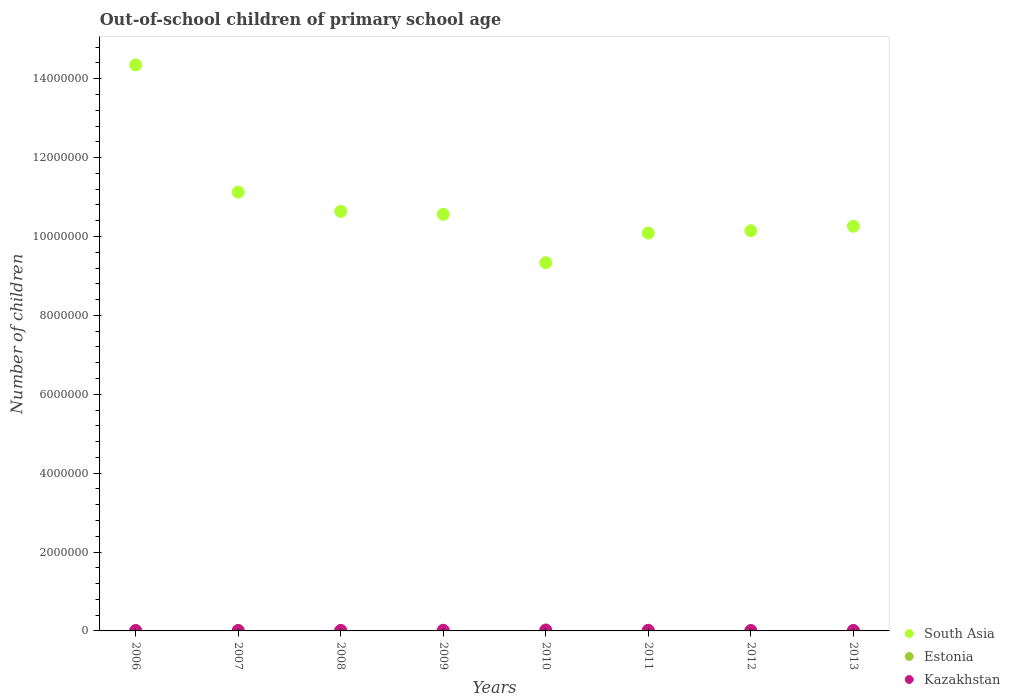How many different coloured dotlines are there?
Make the answer very short. 3. What is the number of out-of-school children in Estonia in 2011?
Your answer should be very brief. 2728. Across all years, what is the maximum number of out-of-school children in Kazakhstan?
Your response must be concise. 2.37e+04. Across all years, what is the minimum number of out-of-school children in Kazakhstan?
Your answer should be compact. 1.01e+04. In which year was the number of out-of-school children in Kazakhstan minimum?
Ensure brevity in your answer.  2012. What is the total number of out-of-school children in Kazakhstan in the graph?
Your answer should be very brief. 1.16e+05. What is the difference between the number of out-of-school children in South Asia in 2012 and that in 2013?
Provide a short and direct response. -1.15e+05. What is the difference between the number of out-of-school children in Estonia in 2006 and the number of out-of-school children in Kazakhstan in 2010?
Your response must be concise. -2.13e+04. What is the average number of out-of-school children in South Asia per year?
Offer a very short reply. 1.08e+07. In the year 2009, what is the difference between the number of out-of-school children in South Asia and number of out-of-school children in Estonia?
Provide a succinct answer. 1.06e+07. What is the ratio of the number of out-of-school children in Kazakhstan in 2011 to that in 2012?
Your response must be concise. 1.64. Is the difference between the number of out-of-school children in South Asia in 2009 and 2013 greater than the difference between the number of out-of-school children in Estonia in 2009 and 2013?
Ensure brevity in your answer.  Yes. What is the difference between the highest and the second highest number of out-of-school children in South Asia?
Keep it short and to the point. 3.23e+06. What is the difference between the highest and the lowest number of out-of-school children in South Asia?
Your response must be concise. 5.02e+06. Is the sum of the number of out-of-school children in South Asia in 2007 and 2010 greater than the maximum number of out-of-school children in Kazakhstan across all years?
Provide a short and direct response. Yes. Is it the case that in every year, the sum of the number of out-of-school children in Kazakhstan and number of out-of-school children in South Asia  is greater than the number of out-of-school children in Estonia?
Provide a succinct answer. Yes. Is the number of out-of-school children in Estonia strictly greater than the number of out-of-school children in South Asia over the years?
Keep it short and to the point. No. How many dotlines are there?
Your answer should be very brief. 3. Are the values on the major ticks of Y-axis written in scientific E-notation?
Your answer should be very brief. No. Does the graph contain any zero values?
Offer a terse response. No. How many legend labels are there?
Your response must be concise. 3. How are the legend labels stacked?
Your response must be concise. Vertical. What is the title of the graph?
Keep it short and to the point. Out-of-school children of primary school age. Does "Macedonia" appear as one of the legend labels in the graph?
Your response must be concise. No. What is the label or title of the Y-axis?
Keep it short and to the point. Number of children. What is the Number of children of South Asia in 2006?
Provide a short and direct response. 1.44e+07. What is the Number of children of Estonia in 2006?
Provide a succinct answer. 2464. What is the Number of children of Kazakhstan in 2006?
Offer a terse response. 1.10e+04. What is the Number of children of South Asia in 2007?
Offer a very short reply. 1.11e+07. What is the Number of children of Estonia in 2007?
Your response must be concise. 3067. What is the Number of children in Kazakhstan in 2007?
Offer a terse response. 1.13e+04. What is the Number of children in South Asia in 2008?
Offer a very short reply. 1.06e+07. What is the Number of children in Estonia in 2008?
Give a very brief answer. 2521. What is the Number of children of Kazakhstan in 2008?
Provide a succinct answer. 1.33e+04. What is the Number of children in South Asia in 2009?
Your answer should be compact. 1.06e+07. What is the Number of children in Estonia in 2009?
Your response must be concise. 2495. What is the Number of children of Kazakhstan in 2009?
Make the answer very short. 1.70e+04. What is the Number of children of South Asia in 2010?
Provide a short and direct response. 9.33e+06. What is the Number of children in Estonia in 2010?
Make the answer very short. 2112. What is the Number of children in Kazakhstan in 2010?
Ensure brevity in your answer.  2.37e+04. What is the Number of children of South Asia in 2011?
Give a very brief answer. 1.01e+07. What is the Number of children of Estonia in 2011?
Your answer should be compact. 2728. What is the Number of children of Kazakhstan in 2011?
Your answer should be very brief. 1.66e+04. What is the Number of children of South Asia in 2012?
Offer a very short reply. 1.01e+07. What is the Number of children of Estonia in 2012?
Give a very brief answer. 2385. What is the Number of children of Kazakhstan in 2012?
Give a very brief answer. 1.01e+04. What is the Number of children in South Asia in 2013?
Make the answer very short. 1.03e+07. What is the Number of children of Estonia in 2013?
Offer a very short reply. 2280. What is the Number of children in Kazakhstan in 2013?
Make the answer very short. 1.25e+04. Across all years, what is the maximum Number of children of South Asia?
Offer a very short reply. 1.44e+07. Across all years, what is the maximum Number of children of Estonia?
Offer a terse response. 3067. Across all years, what is the maximum Number of children of Kazakhstan?
Offer a very short reply. 2.37e+04. Across all years, what is the minimum Number of children in South Asia?
Provide a short and direct response. 9.33e+06. Across all years, what is the minimum Number of children in Estonia?
Provide a succinct answer. 2112. Across all years, what is the minimum Number of children of Kazakhstan?
Your response must be concise. 1.01e+04. What is the total Number of children in South Asia in the graph?
Offer a terse response. 8.65e+07. What is the total Number of children of Estonia in the graph?
Keep it short and to the point. 2.01e+04. What is the total Number of children in Kazakhstan in the graph?
Make the answer very short. 1.16e+05. What is the difference between the Number of children of South Asia in 2006 and that in 2007?
Provide a short and direct response. 3.23e+06. What is the difference between the Number of children of Estonia in 2006 and that in 2007?
Give a very brief answer. -603. What is the difference between the Number of children in Kazakhstan in 2006 and that in 2007?
Your answer should be very brief. -242. What is the difference between the Number of children of South Asia in 2006 and that in 2008?
Make the answer very short. 3.71e+06. What is the difference between the Number of children of Estonia in 2006 and that in 2008?
Your answer should be very brief. -57. What is the difference between the Number of children of Kazakhstan in 2006 and that in 2008?
Your response must be concise. -2242. What is the difference between the Number of children in South Asia in 2006 and that in 2009?
Provide a succinct answer. 3.79e+06. What is the difference between the Number of children of Estonia in 2006 and that in 2009?
Offer a terse response. -31. What is the difference between the Number of children of Kazakhstan in 2006 and that in 2009?
Offer a very short reply. -5917. What is the difference between the Number of children in South Asia in 2006 and that in 2010?
Your response must be concise. 5.02e+06. What is the difference between the Number of children of Estonia in 2006 and that in 2010?
Your answer should be compact. 352. What is the difference between the Number of children of Kazakhstan in 2006 and that in 2010?
Your answer should be very brief. -1.27e+04. What is the difference between the Number of children of South Asia in 2006 and that in 2011?
Ensure brevity in your answer.  4.26e+06. What is the difference between the Number of children in Estonia in 2006 and that in 2011?
Keep it short and to the point. -264. What is the difference between the Number of children in Kazakhstan in 2006 and that in 2011?
Offer a very short reply. -5518. What is the difference between the Number of children of South Asia in 2006 and that in 2012?
Keep it short and to the point. 4.21e+06. What is the difference between the Number of children of Estonia in 2006 and that in 2012?
Make the answer very short. 79. What is the difference between the Number of children of Kazakhstan in 2006 and that in 2012?
Offer a terse response. 932. What is the difference between the Number of children of South Asia in 2006 and that in 2013?
Provide a short and direct response. 4.09e+06. What is the difference between the Number of children in Estonia in 2006 and that in 2013?
Your answer should be very brief. 184. What is the difference between the Number of children of Kazakhstan in 2006 and that in 2013?
Your answer should be very brief. -1473. What is the difference between the Number of children in South Asia in 2007 and that in 2008?
Give a very brief answer. 4.87e+05. What is the difference between the Number of children of Estonia in 2007 and that in 2008?
Provide a short and direct response. 546. What is the difference between the Number of children in Kazakhstan in 2007 and that in 2008?
Your response must be concise. -2000. What is the difference between the Number of children of South Asia in 2007 and that in 2009?
Your answer should be very brief. 5.61e+05. What is the difference between the Number of children of Estonia in 2007 and that in 2009?
Make the answer very short. 572. What is the difference between the Number of children in Kazakhstan in 2007 and that in 2009?
Your answer should be compact. -5675. What is the difference between the Number of children of South Asia in 2007 and that in 2010?
Your response must be concise. 1.79e+06. What is the difference between the Number of children of Estonia in 2007 and that in 2010?
Offer a very short reply. 955. What is the difference between the Number of children of Kazakhstan in 2007 and that in 2010?
Your response must be concise. -1.24e+04. What is the difference between the Number of children in South Asia in 2007 and that in 2011?
Keep it short and to the point. 1.04e+06. What is the difference between the Number of children in Estonia in 2007 and that in 2011?
Provide a succinct answer. 339. What is the difference between the Number of children in Kazakhstan in 2007 and that in 2011?
Give a very brief answer. -5276. What is the difference between the Number of children of South Asia in 2007 and that in 2012?
Provide a short and direct response. 9.79e+05. What is the difference between the Number of children in Estonia in 2007 and that in 2012?
Make the answer very short. 682. What is the difference between the Number of children of Kazakhstan in 2007 and that in 2012?
Offer a very short reply. 1174. What is the difference between the Number of children of South Asia in 2007 and that in 2013?
Ensure brevity in your answer.  8.64e+05. What is the difference between the Number of children of Estonia in 2007 and that in 2013?
Provide a succinct answer. 787. What is the difference between the Number of children of Kazakhstan in 2007 and that in 2013?
Provide a short and direct response. -1231. What is the difference between the Number of children of South Asia in 2008 and that in 2009?
Offer a very short reply. 7.44e+04. What is the difference between the Number of children of Kazakhstan in 2008 and that in 2009?
Ensure brevity in your answer.  -3675. What is the difference between the Number of children of South Asia in 2008 and that in 2010?
Make the answer very short. 1.30e+06. What is the difference between the Number of children in Estonia in 2008 and that in 2010?
Make the answer very short. 409. What is the difference between the Number of children in Kazakhstan in 2008 and that in 2010?
Provide a succinct answer. -1.04e+04. What is the difference between the Number of children of South Asia in 2008 and that in 2011?
Provide a short and direct response. 5.51e+05. What is the difference between the Number of children of Estonia in 2008 and that in 2011?
Offer a very short reply. -207. What is the difference between the Number of children of Kazakhstan in 2008 and that in 2011?
Provide a short and direct response. -3276. What is the difference between the Number of children in South Asia in 2008 and that in 2012?
Provide a short and direct response. 4.92e+05. What is the difference between the Number of children of Estonia in 2008 and that in 2012?
Offer a very short reply. 136. What is the difference between the Number of children in Kazakhstan in 2008 and that in 2012?
Give a very brief answer. 3174. What is the difference between the Number of children of South Asia in 2008 and that in 2013?
Keep it short and to the point. 3.78e+05. What is the difference between the Number of children of Estonia in 2008 and that in 2013?
Make the answer very short. 241. What is the difference between the Number of children in Kazakhstan in 2008 and that in 2013?
Offer a terse response. 769. What is the difference between the Number of children of South Asia in 2009 and that in 2010?
Offer a very short reply. 1.23e+06. What is the difference between the Number of children in Estonia in 2009 and that in 2010?
Give a very brief answer. 383. What is the difference between the Number of children in Kazakhstan in 2009 and that in 2010?
Your response must be concise. -6757. What is the difference between the Number of children of South Asia in 2009 and that in 2011?
Keep it short and to the point. 4.76e+05. What is the difference between the Number of children of Estonia in 2009 and that in 2011?
Your answer should be very brief. -233. What is the difference between the Number of children in Kazakhstan in 2009 and that in 2011?
Offer a very short reply. 399. What is the difference between the Number of children of South Asia in 2009 and that in 2012?
Your response must be concise. 4.18e+05. What is the difference between the Number of children of Estonia in 2009 and that in 2012?
Make the answer very short. 110. What is the difference between the Number of children in Kazakhstan in 2009 and that in 2012?
Your answer should be very brief. 6849. What is the difference between the Number of children of South Asia in 2009 and that in 2013?
Your response must be concise. 3.03e+05. What is the difference between the Number of children in Estonia in 2009 and that in 2013?
Offer a terse response. 215. What is the difference between the Number of children of Kazakhstan in 2009 and that in 2013?
Your answer should be compact. 4444. What is the difference between the Number of children of South Asia in 2010 and that in 2011?
Make the answer very short. -7.51e+05. What is the difference between the Number of children of Estonia in 2010 and that in 2011?
Offer a terse response. -616. What is the difference between the Number of children in Kazakhstan in 2010 and that in 2011?
Make the answer very short. 7156. What is the difference between the Number of children of South Asia in 2010 and that in 2012?
Keep it short and to the point. -8.10e+05. What is the difference between the Number of children of Estonia in 2010 and that in 2012?
Ensure brevity in your answer.  -273. What is the difference between the Number of children in Kazakhstan in 2010 and that in 2012?
Your answer should be compact. 1.36e+04. What is the difference between the Number of children in South Asia in 2010 and that in 2013?
Give a very brief answer. -9.24e+05. What is the difference between the Number of children of Estonia in 2010 and that in 2013?
Your answer should be compact. -168. What is the difference between the Number of children in Kazakhstan in 2010 and that in 2013?
Provide a succinct answer. 1.12e+04. What is the difference between the Number of children of South Asia in 2011 and that in 2012?
Offer a very short reply. -5.81e+04. What is the difference between the Number of children of Estonia in 2011 and that in 2012?
Ensure brevity in your answer.  343. What is the difference between the Number of children of Kazakhstan in 2011 and that in 2012?
Ensure brevity in your answer.  6450. What is the difference between the Number of children in South Asia in 2011 and that in 2013?
Your answer should be compact. -1.73e+05. What is the difference between the Number of children in Estonia in 2011 and that in 2013?
Your answer should be compact. 448. What is the difference between the Number of children in Kazakhstan in 2011 and that in 2013?
Offer a terse response. 4045. What is the difference between the Number of children in South Asia in 2012 and that in 2013?
Offer a very short reply. -1.15e+05. What is the difference between the Number of children in Estonia in 2012 and that in 2013?
Offer a very short reply. 105. What is the difference between the Number of children in Kazakhstan in 2012 and that in 2013?
Keep it short and to the point. -2405. What is the difference between the Number of children of South Asia in 2006 and the Number of children of Estonia in 2007?
Offer a terse response. 1.43e+07. What is the difference between the Number of children of South Asia in 2006 and the Number of children of Kazakhstan in 2007?
Provide a succinct answer. 1.43e+07. What is the difference between the Number of children in Estonia in 2006 and the Number of children in Kazakhstan in 2007?
Your response must be concise. -8824. What is the difference between the Number of children of South Asia in 2006 and the Number of children of Estonia in 2008?
Your answer should be compact. 1.43e+07. What is the difference between the Number of children of South Asia in 2006 and the Number of children of Kazakhstan in 2008?
Your answer should be very brief. 1.43e+07. What is the difference between the Number of children in Estonia in 2006 and the Number of children in Kazakhstan in 2008?
Your answer should be compact. -1.08e+04. What is the difference between the Number of children in South Asia in 2006 and the Number of children in Estonia in 2009?
Give a very brief answer. 1.43e+07. What is the difference between the Number of children of South Asia in 2006 and the Number of children of Kazakhstan in 2009?
Make the answer very short. 1.43e+07. What is the difference between the Number of children of Estonia in 2006 and the Number of children of Kazakhstan in 2009?
Keep it short and to the point. -1.45e+04. What is the difference between the Number of children in South Asia in 2006 and the Number of children in Estonia in 2010?
Give a very brief answer. 1.43e+07. What is the difference between the Number of children in South Asia in 2006 and the Number of children in Kazakhstan in 2010?
Offer a terse response. 1.43e+07. What is the difference between the Number of children of Estonia in 2006 and the Number of children of Kazakhstan in 2010?
Keep it short and to the point. -2.13e+04. What is the difference between the Number of children of South Asia in 2006 and the Number of children of Estonia in 2011?
Offer a terse response. 1.43e+07. What is the difference between the Number of children in South Asia in 2006 and the Number of children in Kazakhstan in 2011?
Provide a short and direct response. 1.43e+07. What is the difference between the Number of children of Estonia in 2006 and the Number of children of Kazakhstan in 2011?
Your response must be concise. -1.41e+04. What is the difference between the Number of children of South Asia in 2006 and the Number of children of Estonia in 2012?
Provide a succinct answer. 1.43e+07. What is the difference between the Number of children of South Asia in 2006 and the Number of children of Kazakhstan in 2012?
Provide a succinct answer. 1.43e+07. What is the difference between the Number of children of Estonia in 2006 and the Number of children of Kazakhstan in 2012?
Your answer should be very brief. -7650. What is the difference between the Number of children in South Asia in 2006 and the Number of children in Estonia in 2013?
Keep it short and to the point. 1.43e+07. What is the difference between the Number of children in South Asia in 2006 and the Number of children in Kazakhstan in 2013?
Give a very brief answer. 1.43e+07. What is the difference between the Number of children in Estonia in 2006 and the Number of children in Kazakhstan in 2013?
Offer a terse response. -1.01e+04. What is the difference between the Number of children of South Asia in 2007 and the Number of children of Estonia in 2008?
Your answer should be compact. 1.11e+07. What is the difference between the Number of children of South Asia in 2007 and the Number of children of Kazakhstan in 2008?
Make the answer very short. 1.11e+07. What is the difference between the Number of children of Estonia in 2007 and the Number of children of Kazakhstan in 2008?
Give a very brief answer. -1.02e+04. What is the difference between the Number of children in South Asia in 2007 and the Number of children in Estonia in 2009?
Your response must be concise. 1.11e+07. What is the difference between the Number of children of South Asia in 2007 and the Number of children of Kazakhstan in 2009?
Make the answer very short. 1.11e+07. What is the difference between the Number of children in Estonia in 2007 and the Number of children in Kazakhstan in 2009?
Give a very brief answer. -1.39e+04. What is the difference between the Number of children in South Asia in 2007 and the Number of children in Estonia in 2010?
Give a very brief answer. 1.11e+07. What is the difference between the Number of children in South Asia in 2007 and the Number of children in Kazakhstan in 2010?
Offer a terse response. 1.11e+07. What is the difference between the Number of children of Estonia in 2007 and the Number of children of Kazakhstan in 2010?
Your answer should be very brief. -2.07e+04. What is the difference between the Number of children of South Asia in 2007 and the Number of children of Estonia in 2011?
Provide a short and direct response. 1.11e+07. What is the difference between the Number of children in South Asia in 2007 and the Number of children in Kazakhstan in 2011?
Your response must be concise. 1.11e+07. What is the difference between the Number of children in Estonia in 2007 and the Number of children in Kazakhstan in 2011?
Your answer should be compact. -1.35e+04. What is the difference between the Number of children of South Asia in 2007 and the Number of children of Estonia in 2012?
Provide a short and direct response. 1.11e+07. What is the difference between the Number of children of South Asia in 2007 and the Number of children of Kazakhstan in 2012?
Keep it short and to the point. 1.11e+07. What is the difference between the Number of children in Estonia in 2007 and the Number of children in Kazakhstan in 2012?
Make the answer very short. -7047. What is the difference between the Number of children of South Asia in 2007 and the Number of children of Estonia in 2013?
Provide a short and direct response. 1.11e+07. What is the difference between the Number of children in South Asia in 2007 and the Number of children in Kazakhstan in 2013?
Your answer should be very brief. 1.11e+07. What is the difference between the Number of children in Estonia in 2007 and the Number of children in Kazakhstan in 2013?
Your answer should be very brief. -9452. What is the difference between the Number of children of South Asia in 2008 and the Number of children of Estonia in 2009?
Make the answer very short. 1.06e+07. What is the difference between the Number of children of South Asia in 2008 and the Number of children of Kazakhstan in 2009?
Ensure brevity in your answer.  1.06e+07. What is the difference between the Number of children in Estonia in 2008 and the Number of children in Kazakhstan in 2009?
Offer a very short reply. -1.44e+04. What is the difference between the Number of children of South Asia in 2008 and the Number of children of Estonia in 2010?
Offer a terse response. 1.06e+07. What is the difference between the Number of children of South Asia in 2008 and the Number of children of Kazakhstan in 2010?
Offer a very short reply. 1.06e+07. What is the difference between the Number of children in Estonia in 2008 and the Number of children in Kazakhstan in 2010?
Provide a succinct answer. -2.12e+04. What is the difference between the Number of children of South Asia in 2008 and the Number of children of Estonia in 2011?
Your response must be concise. 1.06e+07. What is the difference between the Number of children of South Asia in 2008 and the Number of children of Kazakhstan in 2011?
Offer a terse response. 1.06e+07. What is the difference between the Number of children of Estonia in 2008 and the Number of children of Kazakhstan in 2011?
Your response must be concise. -1.40e+04. What is the difference between the Number of children in South Asia in 2008 and the Number of children in Estonia in 2012?
Make the answer very short. 1.06e+07. What is the difference between the Number of children of South Asia in 2008 and the Number of children of Kazakhstan in 2012?
Ensure brevity in your answer.  1.06e+07. What is the difference between the Number of children of Estonia in 2008 and the Number of children of Kazakhstan in 2012?
Give a very brief answer. -7593. What is the difference between the Number of children of South Asia in 2008 and the Number of children of Estonia in 2013?
Give a very brief answer. 1.06e+07. What is the difference between the Number of children of South Asia in 2008 and the Number of children of Kazakhstan in 2013?
Provide a short and direct response. 1.06e+07. What is the difference between the Number of children in Estonia in 2008 and the Number of children in Kazakhstan in 2013?
Ensure brevity in your answer.  -9998. What is the difference between the Number of children of South Asia in 2009 and the Number of children of Estonia in 2010?
Provide a succinct answer. 1.06e+07. What is the difference between the Number of children of South Asia in 2009 and the Number of children of Kazakhstan in 2010?
Ensure brevity in your answer.  1.05e+07. What is the difference between the Number of children in Estonia in 2009 and the Number of children in Kazakhstan in 2010?
Make the answer very short. -2.12e+04. What is the difference between the Number of children in South Asia in 2009 and the Number of children in Estonia in 2011?
Your answer should be very brief. 1.06e+07. What is the difference between the Number of children in South Asia in 2009 and the Number of children in Kazakhstan in 2011?
Ensure brevity in your answer.  1.05e+07. What is the difference between the Number of children in Estonia in 2009 and the Number of children in Kazakhstan in 2011?
Ensure brevity in your answer.  -1.41e+04. What is the difference between the Number of children in South Asia in 2009 and the Number of children in Estonia in 2012?
Offer a very short reply. 1.06e+07. What is the difference between the Number of children of South Asia in 2009 and the Number of children of Kazakhstan in 2012?
Ensure brevity in your answer.  1.06e+07. What is the difference between the Number of children in Estonia in 2009 and the Number of children in Kazakhstan in 2012?
Offer a terse response. -7619. What is the difference between the Number of children in South Asia in 2009 and the Number of children in Estonia in 2013?
Keep it short and to the point. 1.06e+07. What is the difference between the Number of children of South Asia in 2009 and the Number of children of Kazakhstan in 2013?
Keep it short and to the point. 1.05e+07. What is the difference between the Number of children of Estonia in 2009 and the Number of children of Kazakhstan in 2013?
Your answer should be very brief. -1.00e+04. What is the difference between the Number of children in South Asia in 2010 and the Number of children in Estonia in 2011?
Give a very brief answer. 9.33e+06. What is the difference between the Number of children in South Asia in 2010 and the Number of children in Kazakhstan in 2011?
Your answer should be very brief. 9.32e+06. What is the difference between the Number of children in Estonia in 2010 and the Number of children in Kazakhstan in 2011?
Your answer should be very brief. -1.45e+04. What is the difference between the Number of children in South Asia in 2010 and the Number of children in Estonia in 2012?
Ensure brevity in your answer.  9.33e+06. What is the difference between the Number of children in South Asia in 2010 and the Number of children in Kazakhstan in 2012?
Your answer should be very brief. 9.32e+06. What is the difference between the Number of children in Estonia in 2010 and the Number of children in Kazakhstan in 2012?
Your answer should be very brief. -8002. What is the difference between the Number of children of South Asia in 2010 and the Number of children of Estonia in 2013?
Offer a terse response. 9.33e+06. What is the difference between the Number of children of South Asia in 2010 and the Number of children of Kazakhstan in 2013?
Ensure brevity in your answer.  9.32e+06. What is the difference between the Number of children of Estonia in 2010 and the Number of children of Kazakhstan in 2013?
Ensure brevity in your answer.  -1.04e+04. What is the difference between the Number of children of South Asia in 2011 and the Number of children of Estonia in 2012?
Your answer should be very brief. 1.01e+07. What is the difference between the Number of children in South Asia in 2011 and the Number of children in Kazakhstan in 2012?
Provide a succinct answer. 1.01e+07. What is the difference between the Number of children in Estonia in 2011 and the Number of children in Kazakhstan in 2012?
Provide a short and direct response. -7386. What is the difference between the Number of children in South Asia in 2011 and the Number of children in Estonia in 2013?
Provide a short and direct response. 1.01e+07. What is the difference between the Number of children in South Asia in 2011 and the Number of children in Kazakhstan in 2013?
Offer a very short reply. 1.01e+07. What is the difference between the Number of children in Estonia in 2011 and the Number of children in Kazakhstan in 2013?
Your response must be concise. -9791. What is the difference between the Number of children of South Asia in 2012 and the Number of children of Estonia in 2013?
Offer a very short reply. 1.01e+07. What is the difference between the Number of children of South Asia in 2012 and the Number of children of Kazakhstan in 2013?
Provide a short and direct response. 1.01e+07. What is the difference between the Number of children of Estonia in 2012 and the Number of children of Kazakhstan in 2013?
Offer a terse response. -1.01e+04. What is the average Number of children of South Asia per year?
Offer a terse response. 1.08e+07. What is the average Number of children in Estonia per year?
Give a very brief answer. 2506.5. What is the average Number of children in Kazakhstan per year?
Your answer should be very brief. 1.44e+04. In the year 2006, what is the difference between the Number of children in South Asia and Number of children in Estonia?
Make the answer very short. 1.43e+07. In the year 2006, what is the difference between the Number of children of South Asia and Number of children of Kazakhstan?
Give a very brief answer. 1.43e+07. In the year 2006, what is the difference between the Number of children of Estonia and Number of children of Kazakhstan?
Offer a very short reply. -8582. In the year 2007, what is the difference between the Number of children of South Asia and Number of children of Estonia?
Your answer should be very brief. 1.11e+07. In the year 2007, what is the difference between the Number of children of South Asia and Number of children of Kazakhstan?
Keep it short and to the point. 1.11e+07. In the year 2007, what is the difference between the Number of children in Estonia and Number of children in Kazakhstan?
Offer a terse response. -8221. In the year 2008, what is the difference between the Number of children in South Asia and Number of children in Estonia?
Your answer should be very brief. 1.06e+07. In the year 2008, what is the difference between the Number of children of South Asia and Number of children of Kazakhstan?
Give a very brief answer. 1.06e+07. In the year 2008, what is the difference between the Number of children in Estonia and Number of children in Kazakhstan?
Provide a succinct answer. -1.08e+04. In the year 2009, what is the difference between the Number of children in South Asia and Number of children in Estonia?
Keep it short and to the point. 1.06e+07. In the year 2009, what is the difference between the Number of children of South Asia and Number of children of Kazakhstan?
Offer a terse response. 1.05e+07. In the year 2009, what is the difference between the Number of children of Estonia and Number of children of Kazakhstan?
Offer a terse response. -1.45e+04. In the year 2010, what is the difference between the Number of children of South Asia and Number of children of Estonia?
Your answer should be compact. 9.33e+06. In the year 2010, what is the difference between the Number of children in South Asia and Number of children in Kazakhstan?
Provide a succinct answer. 9.31e+06. In the year 2010, what is the difference between the Number of children of Estonia and Number of children of Kazakhstan?
Offer a terse response. -2.16e+04. In the year 2011, what is the difference between the Number of children of South Asia and Number of children of Estonia?
Provide a short and direct response. 1.01e+07. In the year 2011, what is the difference between the Number of children of South Asia and Number of children of Kazakhstan?
Make the answer very short. 1.01e+07. In the year 2011, what is the difference between the Number of children in Estonia and Number of children in Kazakhstan?
Your response must be concise. -1.38e+04. In the year 2012, what is the difference between the Number of children of South Asia and Number of children of Estonia?
Ensure brevity in your answer.  1.01e+07. In the year 2012, what is the difference between the Number of children of South Asia and Number of children of Kazakhstan?
Your answer should be very brief. 1.01e+07. In the year 2012, what is the difference between the Number of children of Estonia and Number of children of Kazakhstan?
Offer a terse response. -7729. In the year 2013, what is the difference between the Number of children of South Asia and Number of children of Estonia?
Ensure brevity in your answer.  1.03e+07. In the year 2013, what is the difference between the Number of children in South Asia and Number of children in Kazakhstan?
Ensure brevity in your answer.  1.02e+07. In the year 2013, what is the difference between the Number of children of Estonia and Number of children of Kazakhstan?
Your answer should be compact. -1.02e+04. What is the ratio of the Number of children in South Asia in 2006 to that in 2007?
Your response must be concise. 1.29. What is the ratio of the Number of children in Estonia in 2006 to that in 2007?
Ensure brevity in your answer.  0.8. What is the ratio of the Number of children in Kazakhstan in 2006 to that in 2007?
Offer a very short reply. 0.98. What is the ratio of the Number of children of South Asia in 2006 to that in 2008?
Your response must be concise. 1.35. What is the ratio of the Number of children of Estonia in 2006 to that in 2008?
Provide a short and direct response. 0.98. What is the ratio of the Number of children of Kazakhstan in 2006 to that in 2008?
Provide a short and direct response. 0.83. What is the ratio of the Number of children of South Asia in 2006 to that in 2009?
Provide a short and direct response. 1.36. What is the ratio of the Number of children in Estonia in 2006 to that in 2009?
Make the answer very short. 0.99. What is the ratio of the Number of children of Kazakhstan in 2006 to that in 2009?
Give a very brief answer. 0.65. What is the ratio of the Number of children of South Asia in 2006 to that in 2010?
Make the answer very short. 1.54. What is the ratio of the Number of children of Kazakhstan in 2006 to that in 2010?
Give a very brief answer. 0.47. What is the ratio of the Number of children of South Asia in 2006 to that in 2011?
Provide a short and direct response. 1.42. What is the ratio of the Number of children of Estonia in 2006 to that in 2011?
Give a very brief answer. 0.9. What is the ratio of the Number of children of Kazakhstan in 2006 to that in 2011?
Provide a succinct answer. 0.67. What is the ratio of the Number of children of South Asia in 2006 to that in 2012?
Provide a short and direct response. 1.41. What is the ratio of the Number of children in Estonia in 2006 to that in 2012?
Provide a short and direct response. 1.03. What is the ratio of the Number of children of Kazakhstan in 2006 to that in 2012?
Your response must be concise. 1.09. What is the ratio of the Number of children of South Asia in 2006 to that in 2013?
Give a very brief answer. 1.4. What is the ratio of the Number of children of Estonia in 2006 to that in 2013?
Offer a terse response. 1.08. What is the ratio of the Number of children of Kazakhstan in 2006 to that in 2013?
Give a very brief answer. 0.88. What is the ratio of the Number of children of South Asia in 2007 to that in 2008?
Your answer should be compact. 1.05. What is the ratio of the Number of children in Estonia in 2007 to that in 2008?
Your response must be concise. 1.22. What is the ratio of the Number of children in Kazakhstan in 2007 to that in 2008?
Offer a terse response. 0.85. What is the ratio of the Number of children in South Asia in 2007 to that in 2009?
Your answer should be very brief. 1.05. What is the ratio of the Number of children of Estonia in 2007 to that in 2009?
Your answer should be compact. 1.23. What is the ratio of the Number of children in Kazakhstan in 2007 to that in 2009?
Give a very brief answer. 0.67. What is the ratio of the Number of children of South Asia in 2007 to that in 2010?
Give a very brief answer. 1.19. What is the ratio of the Number of children in Estonia in 2007 to that in 2010?
Your answer should be compact. 1.45. What is the ratio of the Number of children in Kazakhstan in 2007 to that in 2010?
Your answer should be compact. 0.48. What is the ratio of the Number of children of South Asia in 2007 to that in 2011?
Your answer should be compact. 1.1. What is the ratio of the Number of children in Estonia in 2007 to that in 2011?
Your answer should be very brief. 1.12. What is the ratio of the Number of children of Kazakhstan in 2007 to that in 2011?
Your answer should be very brief. 0.68. What is the ratio of the Number of children in South Asia in 2007 to that in 2012?
Ensure brevity in your answer.  1.1. What is the ratio of the Number of children of Estonia in 2007 to that in 2012?
Give a very brief answer. 1.29. What is the ratio of the Number of children of Kazakhstan in 2007 to that in 2012?
Give a very brief answer. 1.12. What is the ratio of the Number of children in South Asia in 2007 to that in 2013?
Ensure brevity in your answer.  1.08. What is the ratio of the Number of children in Estonia in 2007 to that in 2013?
Your response must be concise. 1.35. What is the ratio of the Number of children of Kazakhstan in 2007 to that in 2013?
Offer a very short reply. 0.9. What is the ratio of the Number of children in South Asia in 2008 to that in 2009?
Make the answer very short. 1.01. What is the ratio of the Number of children of Estonia in 2008 to that in 2009?
Provide a short and direct response. 1.01. What is the ratio of the Number of children of Kazakhstan in 2008 to that in 2009?
Offer a terse response. 0.78. What is the ratio of the Number of children in South Asia in 2008 to that in 2010?
Keep it short and to the point. 1.14. What is the ratio of the Number of children in Estonia in 2008 to that in 2010?
Ensure brevity in your answer.  1.19. What is the ratio of the Number of children in Kazakhstan in 2008 to that in 2010?
Offer a very short reply. 0.56. What is the ratio of the Number of children of South Asia in 2008 to that in 2011?
Make the answer very short. 1.05. What is the ratio of the Number of children of Estonia in 2008 to that in 2011?
Offer a very short reply. 0.92. What is the ratio of the Number of children in Kazakhstan in 2008 to that in 2011?
Offer a very short reply. 0.8. What is the ratio of the Number of children of South Asia in 2008 to that in 2012?
Your response must be concise. 1.05. What is the ratio of the Number of children of Estonia in 2008 to that in 2012?
Ensure brevity in your answer.  1.06. What is the ratio of the Number of children in Kazakhstan in 2008 to that in 2012?
Give a very brief answer. 1.31. What is the ratio of the Number of children of South Asia in 2008 to that in 2013?
Keep it short and to the point. 1.04. What is the ratio of the Number of children in Estonia in 2008 to that in 2013?
Your response must be concise. 1.11. What is the ratio of the Number of children in Kazakhstan in 2008 to that in 2013?
Provide a succinct answer. 1.06. What is the ratio of the Number of children of South Asia in 2009 to that in 2010?
Give a very brief answer. 1.13. What is the ratio of the Number of children of Estonia in 2009 to that in 2010?
Your answer should be very brief. 1.18. What is the ratio of the Number of children of Kazakhstan in 2009 to that in 2010?
Your response must be concise. 0.72. What is the ratio of the Number of children of South Asia in 2009 to that in 2011?
Provide a succinct answer. 1.05. What is the ratio of the Number of children of Estonia in 2009 to that in 2011?
Provide a short and direct response. 0.91. What is the ratio of the Number of children in Kazakhstan in 2009 to that in 2011?
Make the answer very short. 1.02. What is the ratio of the Number of children of South Asia in 2009 to that in 2012?
Your answer should be compact. 1.04. What is the ratio of the Number of children in Estonia in 2009 to that in 2012?
Your response must be concise. 1.05. What is the ratio of the Number of children of Kazakhstan in 2009 to that in 2012?
Ensure brevity in your answer.  1.68. What is the ratio of the Number of children in South Asia in 2009 to that in 2013?
Provide a short and direct response. 1.03. What is the ratio of the Number of children of Estonia in 2009 to that in 2013?
Your response must be concise. 1.09. What is the ratio of the Number of children in Kazakhstan in 2009 to that in 2013?
Your answer should be compact. 1.35. What is the ratio of the Number of children in South Asia in 2010 to that in 2011?
Give a very brief answer. 0.93. What is the ratio of the Number of children of Estonia in 2010 to that in 2011?
Offer a terse response. 0.77. What is the ratio of the Number of children in Kazakhstan in 2010 to that in 2011?
Provide a succinct answer. 1.43. What is the ratio of the Number of children in South Asia in 2010 to that in 2012?
Offer a terse response. 0.92. What is the ratio of the Number of children in Estonia in 2010 to that in 2012?
Offer a terse response. 0.89. What is the ratio of the Number of children in Kazakhstan in 2010 to that in 2012?
Ensure brevity in your answer.  2.35. What is the ratio of the Number of children in South Asia in 2010 to that in 2013?
Your response must be concise. 0.91. What is the ratio of the Number of children in Estonia in 2010 to that in 2013?
Offer a terse response. 0.93. What is the ratio of the Number of children of Kazakhstan in 2010 to that in 2013?
Keep it short and to the point. 1.89. What is the ratio of the Number of children of Estonia in 2011 to that in 2012?
Provide a short and direct response. 1.14. What is the ratio of the Number of children of Kazakhstan in 2011 to that in 2012?
Provide a succinct answer. 1.64. What is the ratio of the Number of children in South Asia in 2011 to that in 2013?
Your answer should be very brief. 0.98. What is the ratio of the Number of children of Estonia in 2011 to that in 2013?
Make the answer very short. 1.2. What is the ratio of the Number of children in Kazakhstan in 2011 to that in 2013?
Offer a very short reply. 1.32. What is the ratio of the Number of children of South Asia in 2012 to that in 2013?
Your answer should be very brief. 0.99. What is the ratio of the Number of children of Estonia in 2012 to that in 2013?
Keep it short and to the point. 1.05. What is the ratio of the Number of children of Kazakhstan in 2012 to that in 2013?
Your response must be concise. 0.81. What is the difference between the highest and the second highest Number of children of South Asia?
Your response must be concise. 3.23e+06. What is the difference between the highest and the second highest Number of children of Estonia?
Make the answer very short. 339. What is the difference between the highest and the second highest Number of children in Kazakhstan?
Your response must be concise. 6757. What is the difference between the highest and the lowest Number of children in South Asia?
Provide a short and direct response. 5.02e+06. What is the difference between the highest and the lowest Number of children of Estonia?
Your answer should be compact. 955. What is the difference between the highest and the lowest Number of children in Kazakhstan?
Your response must be concise. 1.36e+04. 